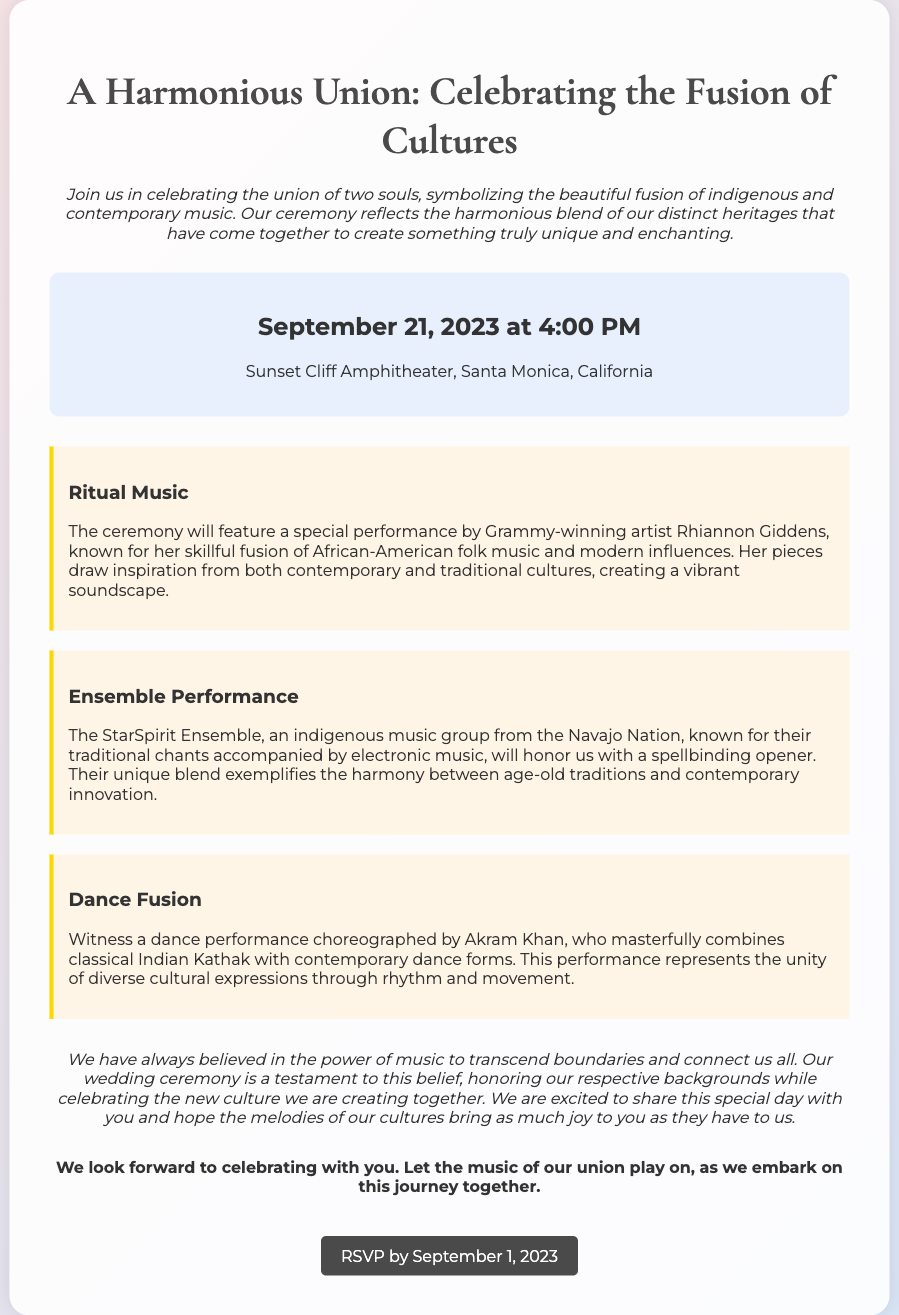What is the event date? The event date is clearly stated in the document, which is September 21, 2023.
Answer: September 21, 2023 What time does the ceremony start? The ceremony start time is included in the date location section of the invitation, which mentions the start time as 4:00 PM.
Answer: 4:00 PM Where is the wedding venue? The venue is mentioned in the same section as the date and time, listing it as Sunset Cliff Amphitheater, Santa Monica, California.
Answer: Sunset Cliff Amphitheater, Santa Monica, California Who is performing at the ceremony? The document specifically names Rhiannon Giddens as the performing artist during the ceremony.
Answer: Rhiannon Giddens What type of music will the StarSpirit Ensemble combine? The text describes that the StarSpirit Ensemble combines traditional chants with electronic music.
Answer: Traditional chants and electronic music What does the wedding symbolize? The invitation states that the wedding symbolizes the beautiful fusion of indigenous and contemporary music.
Answer: Fusion of indigenous and contemporary music What unique element does Akram Khan bring to the dance performance? The document explains that Akram Khan combines classical Indian Kathak with contemporary dance forms.
Answer: Classical Indian Kathak What is the RSVP deadline? The RSVP deadline is clearly marked as September 1, 2023, in the closing section of the invitation.
Answer: September 1, 2023 What is the main theme of this wedding invitation? The theme is articulated in the title, emphasizing the celebration of cultural fusion through music.
Answer: Cultural fusion through music 